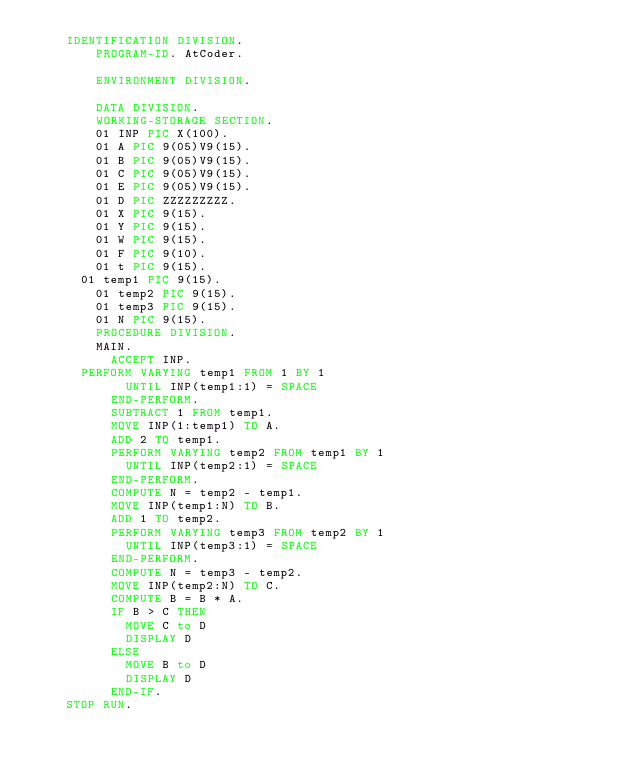Convert code to text. <code><loc_0><loc_0><loc_500><loc_500><_COBOL_>		IDENTIFICATION DIVISION.
        PROGRAM-ID. AtCoder.
      
        ENVIRONMENT DIVISION.
      
        DATA DIVISION.
        WORKING-STORAGE SECTION.
        01 INP PIC X(100).
        01 A PIC 9(05)V9(15).
        01 B PIC 9(05)V9(15).
      	01 C PIC 9(05)V9(15).
      	01 E PIC 9(05)V9(15).
      	01 D PIC ZZZZZZZZZ.
      	01 X PIC 9(15).
      	01 Y PIC 9(15).
      	01 W PIC 9(15).
      	01 F PIC 9(10).
      	01 t PIC 9(15).
	    01 temp1 PIC 9(15).
        01 temp2 PIC 9(15).
      	01 temp3 PIC 9(15).
        01 N PIC 9(15).
        PROCEDURE DIVISION.
      	MAIN.
      		ACCEPT INP.
			PERFORM VARYING temp1 FROM 1 BY 1
            UNTIL INP(temp1:1) = SPACE
        	END-PERFORM.
        	SUBTRACT 1 FROM temp1.
        	MOVE INP(1:temp1) TO A.
        	ADD 2 TO temp1.
        	PERFORM VARYING temp2 FROM temp1 BY 1
            UNTIL INP(temp2:1) = SPACE
        	END-PERFORM.
        	COMPUTE N = temp2 - temp1.
        	MOVE INP(temp1:N) TO B.
      		ADD 1 TO temp2.
      		PERFORM VARYING temp3 FROM temp2 BY 1
            UNTIL INP(temp3:1) = SPACE
        	END-PERFORM.
        	COMPUTE N = temp3 - temp2.
        	MOVE INP(temp2:N) TO C.
      		COMPUTE B = B * A.
      		IF B > C THEN
      			MOVE C to D
      			DISPLAY D
      		ELSE
      			MOVE B to D
      			DISPLAY D
      		END-IF.
		STOP RUN.</code> 